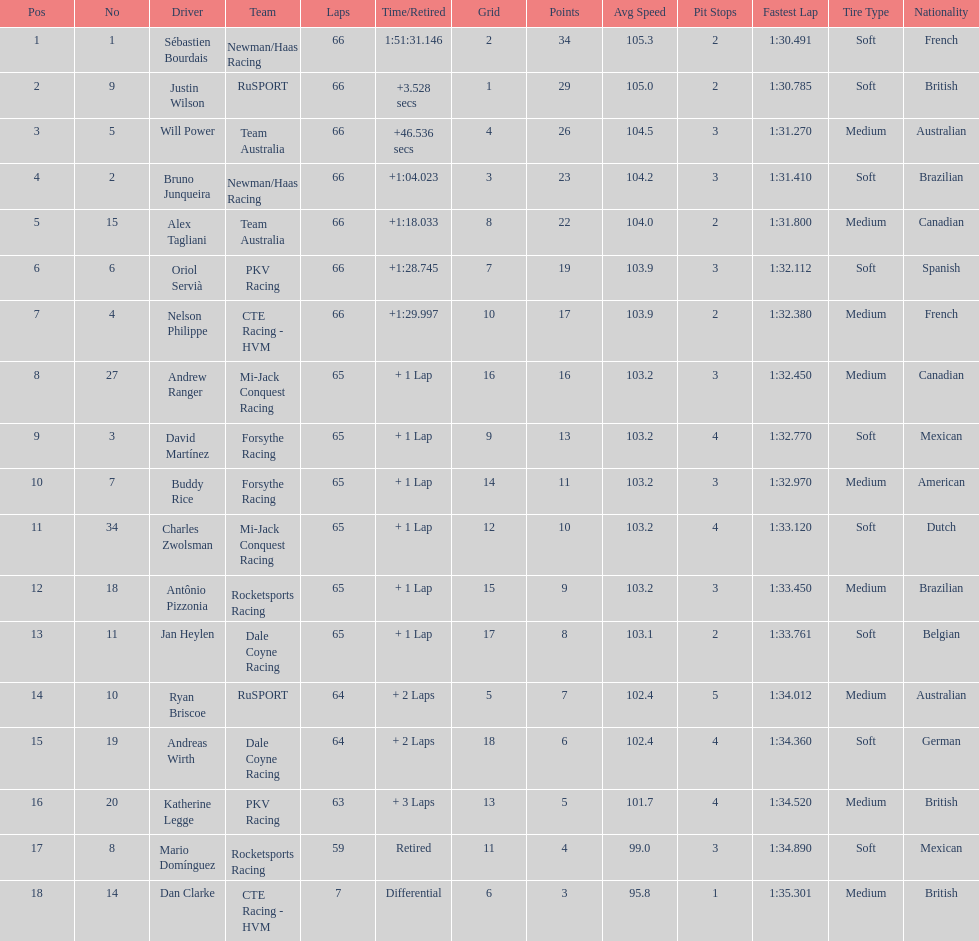Which country is represented by the most drivers? United Kingdom. 